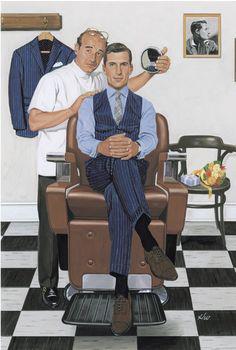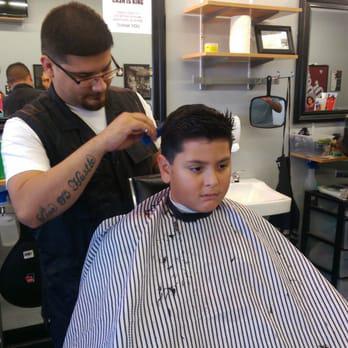The first image is the image on the left, the second image is the image on the right. For the images shown, is this caption "A forward-facing man who is not a customer sits on a barber chair in the center of one scene." true? Answer yes or no. No. The first image is the image on the left, the second image is the image on the right. Analyze the images presented: Is the assertion "At least one person is wearing eyeglasses in one of the images." valid? Answer yes or no. Yes. 